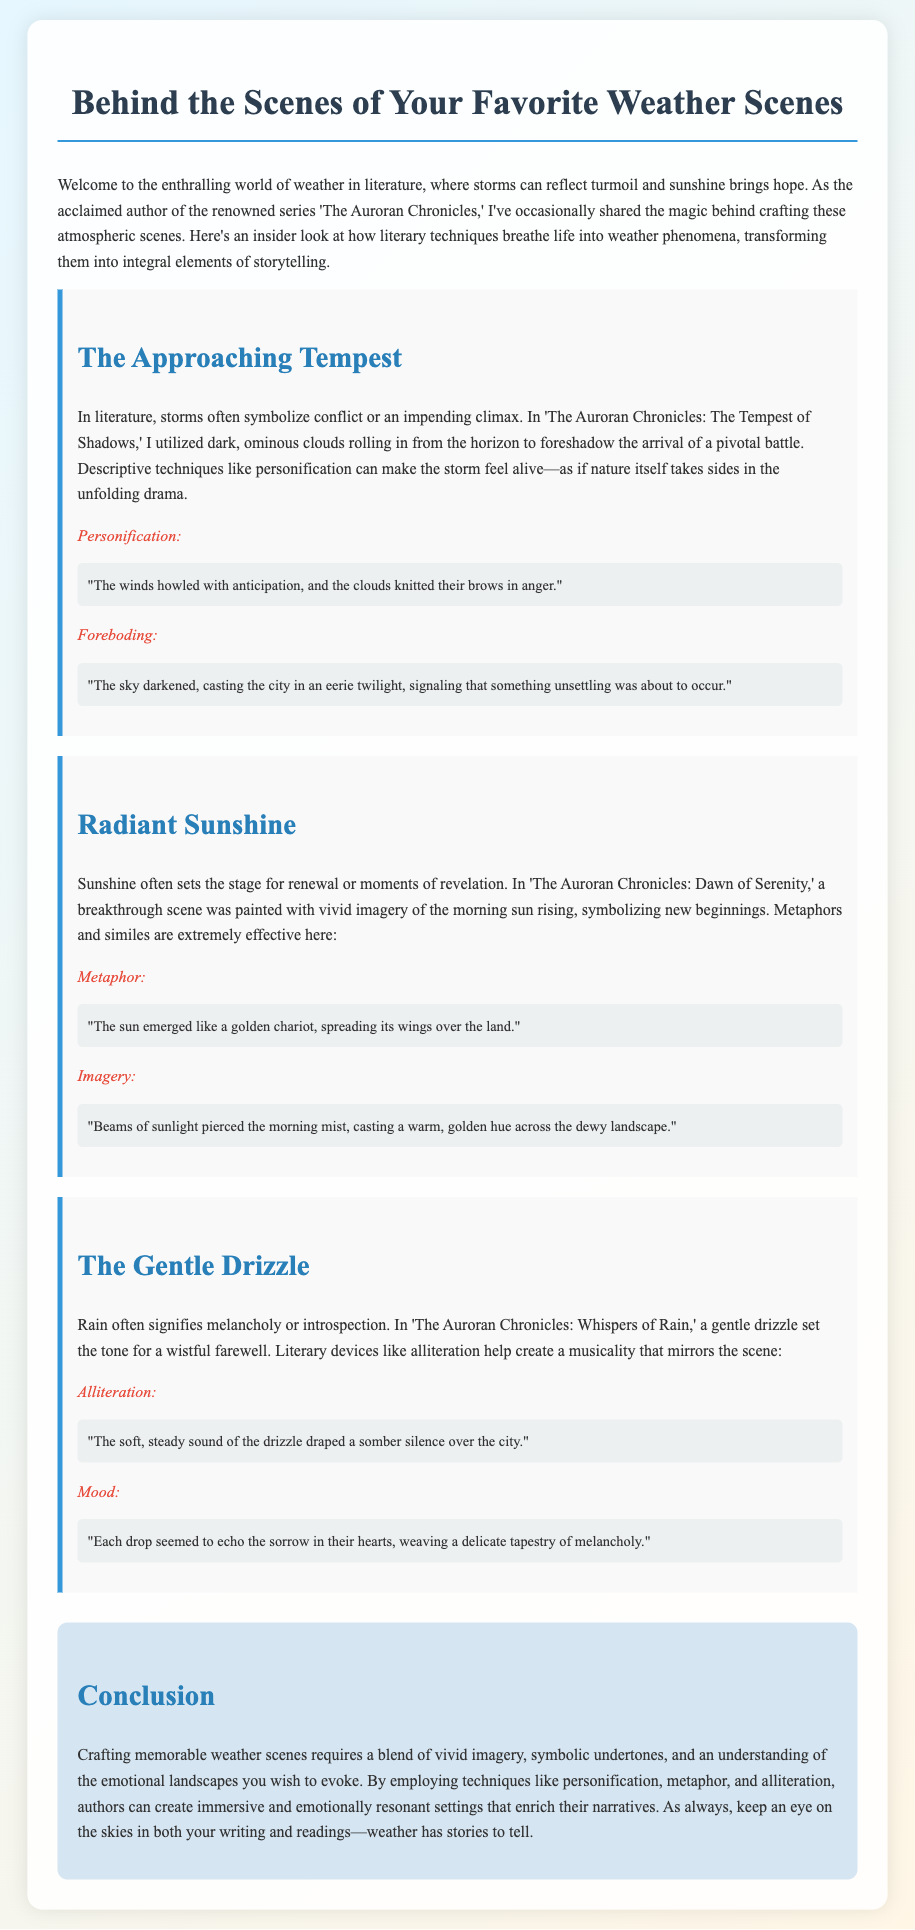What literary technique is used to describe storms in 'The Auroran Chronicles: The Tempest of Shadows'? The technique used is personification, which makes the storm feel alive and impactful within the narrative.
Answer: Personification What does radiant sunshine symbolize in 'The Auroran Chronicles: Dawn of Serenity'? Sunshine symbolizes renewal or moments of revelation in the narrative, reflecting new beginnings.
Answer: Renewal What literary device is highlighted in the scene with the gentle drizzle? The document emphasizes alliteration, used to create a musical quality that complements the wistful atmosphere.
Answer: Alliteration In which book is the scene with dark ominous clouds featured? This scene is featured in 'The Auroran Chronicles: The Tempest of Shadows,' which foreshadows a pivotal battle.
Answer: The Tempest of Shadows What imagery technique is used to describe the morning sun? The document describes the use of vivid imagery to paint a picture of the sun rising and symbolizing new beginnings.
Answer: Imagery How does rain affect the mood in 'The Auroran Chronicles: Whispers of Rain'? Rain signifies melancholy or introspection, contributing to a somber tone during a farewell scene.
Answer: Melancholy What emotional landscapes do weather descriptions aim to evoke? The descriptions aim to evoke various emotional landscapes, enriching the storytelling through relatable atmospheres.
Answer: Emotional landscapes What is the main purpose of using literary techniques in weather scenes? The main purpose is to create immersive and emotionally resonant settings that enhance the narrative's depth.
Answer: Immersive settings 